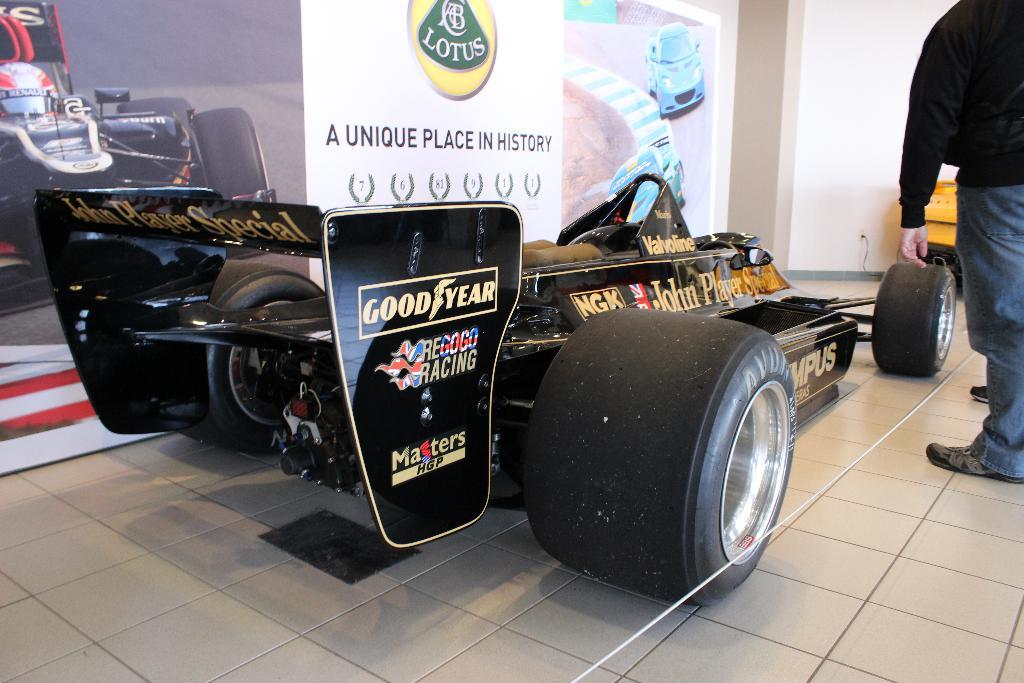What is the main subject in the image? There is a vehicle in the image. Can you describe the man in the image? A man is standing on the floor in the image. What else can be seen on the walls or surfaces in the image? There are posters in the image. What is visible in the background of the image? There is an object and a wall visible in the background of the image. What does the notebook smell like in the image? There is no notebook present in the image, so it cannot be determined what it might smell like. 